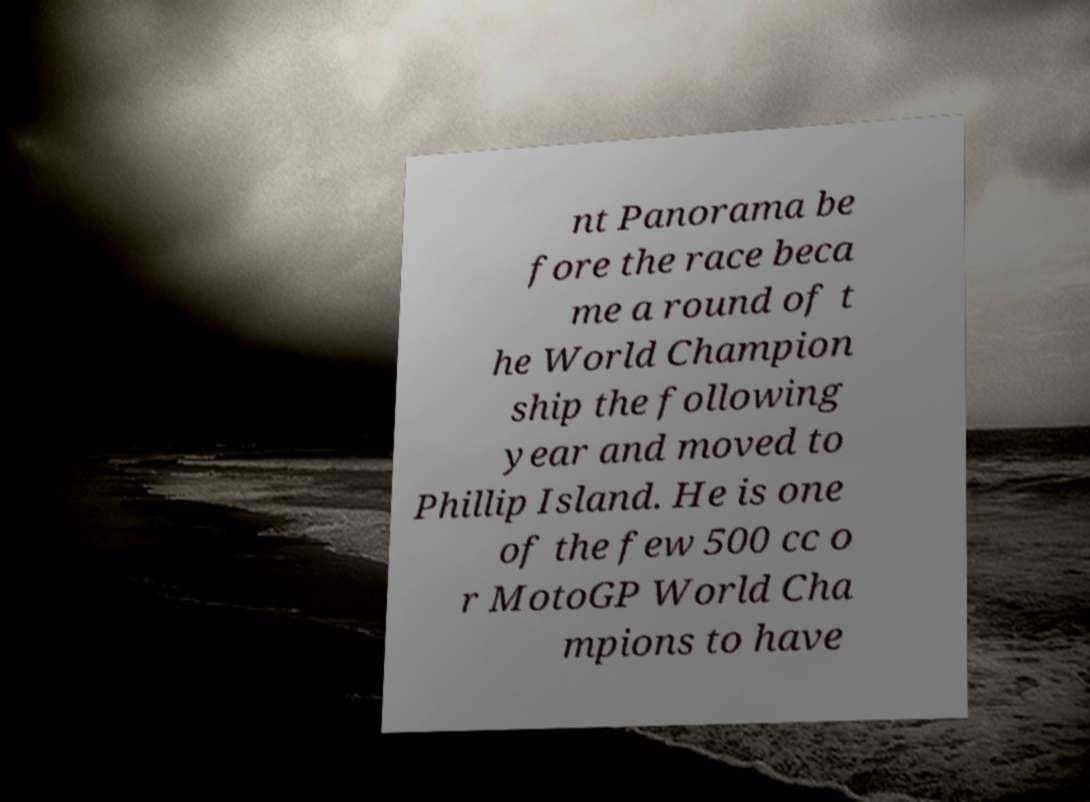Could you extract and type out the text from this image? nt Panorama be fore the race beca me a round of t he World Champion ship the following year and moved to Phillip Island. He is one of the few 500 cc o r MotoGP World Cha mpions to have 